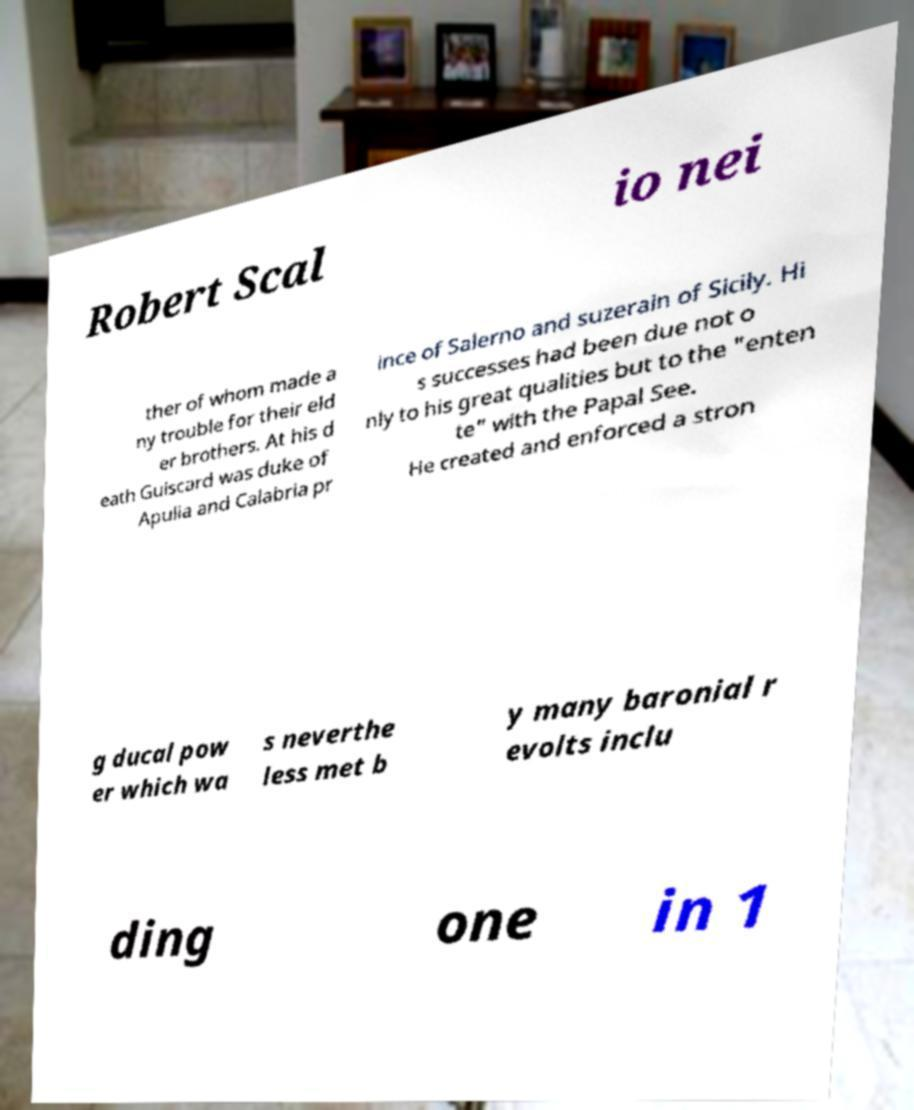What messages or text are displayed in this image? I need them in a readable, typed format. Robert Scal io nei ther of whom made a ny trouble for their eld er brothers. At his d eath Guiscard was duke of Apulia and Calabria pr ince of Salerno and suzerain of Sicily. Hi s successes had been due not o nly to his great qualities but to the "enten te" with the Papal See. He created and enforced a stron g ducal pow er which wa s neverthe less met b y many baronial r evolts inclu ding one in 1 